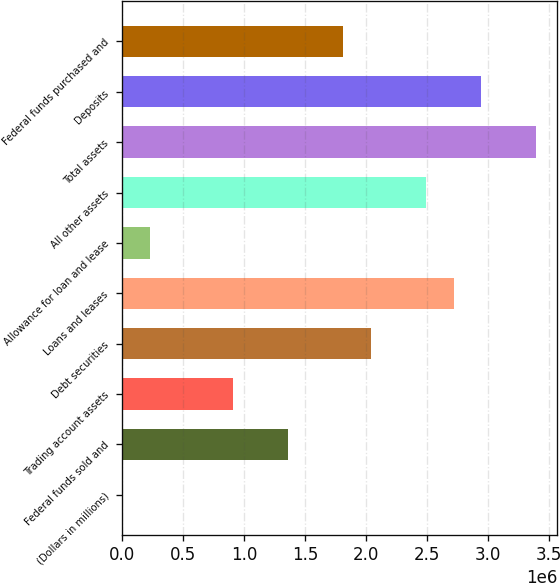Convert chart to OTSL. <chart><loc_0><loc_0><loc_500><loc_500><bar_chart><fcel>(Dollars in millions)<fcel>Federal funds sold and<fcel>Trading account assets<fcel>Debt securities<fcel>Loans and leases<fcel>Allowance for loan and lease<fcel>All other assets<fcel>Total assets<fcel>Deposits<fcel>Federal funds purchased and<nl><fcel>2010<fcel>1.35975e+06<fcel>907170<fcel>2.03862e+06<fcel>2.71749e+06<fcel>228300<fcel>2.4912e+06<fcel>3.39636e+06<fcel>2.94378e+06<fcel>1.81233e+06<nl></chart> 